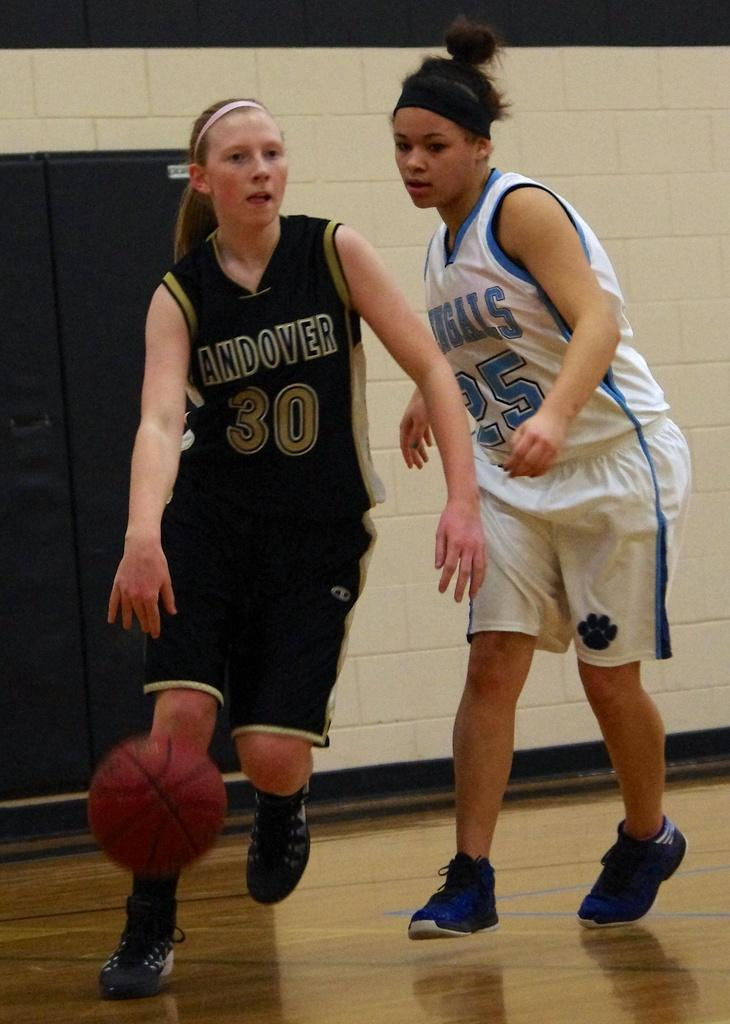<image>
Give a short and clear explanation of the subsequent image. two girls playing basketball with one wearing 30 